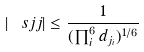Convert formula to latex. <formula><loc_0><loc_0><loc_500><loc_500>\left | \ s j { j } \right | \leq \frac { 1 } { ( \prod _ { i } ^ { 6 } d _ { j _ { i } } ) ^ { 1 / 6 } }</formula> 